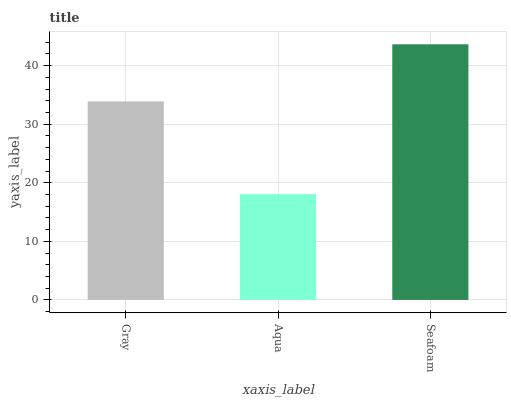Is Aqua the minimum?
Answer yes or no. Yes. Is Seafoam the maximum?
Answer yes or no. Yes. Is Seafoam the minimum?
Answer yes or no. No. Is Aqua the maximum?
Answer yes or no. No. Is Seafoam greater than Aqua?
Answer yes or no. Yes. Is Aqua less than Seafoam?
Answer yes or no. Yes. Is Aqua greater than Seafoam?
Answer yes or no. No. Is Seafoam less than Aqua?
Answer yes or no. No. Is Gray the high median?
Answer yes or no. Yes. Is Gray the low median?
Answer yes or no. Yes. Is Seafoam the high median?
Answer yes or no. No. Is Aqua the low median?
Answer yes or no. No. 